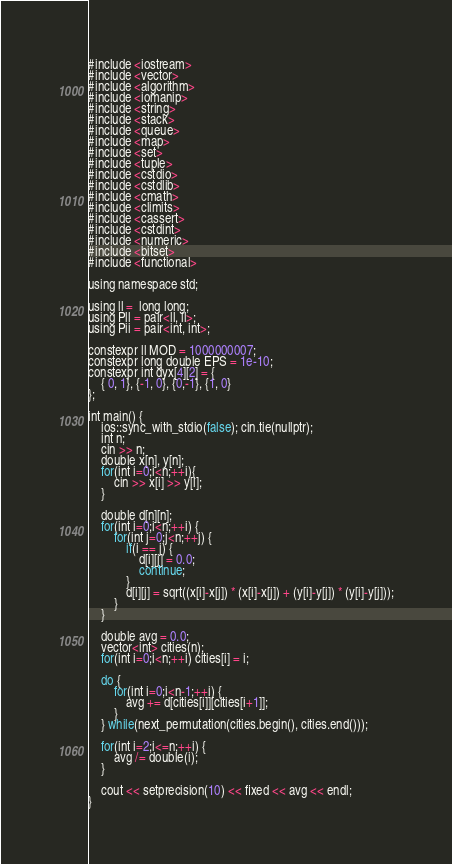Convert code to text. <code><loc_0><loc_0><loc_500><loc_500><_Rust_>#include <iostream>
#include <vector>
#include <algorithm>
#include <iomanip>
#include <string>
#include <stack>
#include <queue>
#include <map>
#include <set>
#include <tuple>
#include <cstdio>
#include <cstdlib>
#include <cmath>
#include <climits>
#include <cassert>
#include <cstdint>
#include <numeric>
#include <bitset>
#include <functional>

using namespace std;

using ll =  long long;
using Pll = pair<ll, ll>;
using Pii = pair<int, int>;

constexpr ll MOD = 1000000007;
constexpr long double EPS = 1e-10;
constexpr int dyx[4][2] = {
    { 0, 1}, {-1, 0}, {0,-1}, {1, 0}
};

int main() {
    ios::sync_with_stdio(false); cin.tie(nullptr);
    int n;
    cin >> n;
    double x[n], y[n];
    for(int i=0;i<n;++i){
        cin >> x[i] >> y[i];
    }

    double d[n][n];
    for(int i=0;i<n;++i) {
        for(int j=0;j<n;++j) {
            if(i == j) {
                d[i][j] = 0.0;
                continue;
            }
            d[i][j] = sqrt((x[i]-x[j]) * (x[i]-x[j]) + (y[i]-y[j]) * (y[i]-y[j]));
        }
    }

    double avg = 0.0;
    vector<int> cities(n);
    for(int i=0;i<n;++i) cities[i] = i;
    
    do {
        for(int i=0;i<n-1;++i) {
            avg += d[cities[i]][cities[i+1]];
        }
    } while(next_permutation(cities.begin(), cities.end()));

    for(int i=2;i<=n;++i) {
        avg /= double(i);
    }

    cout << setprecision(10) << fixed << avg << endl;
}
</code> 